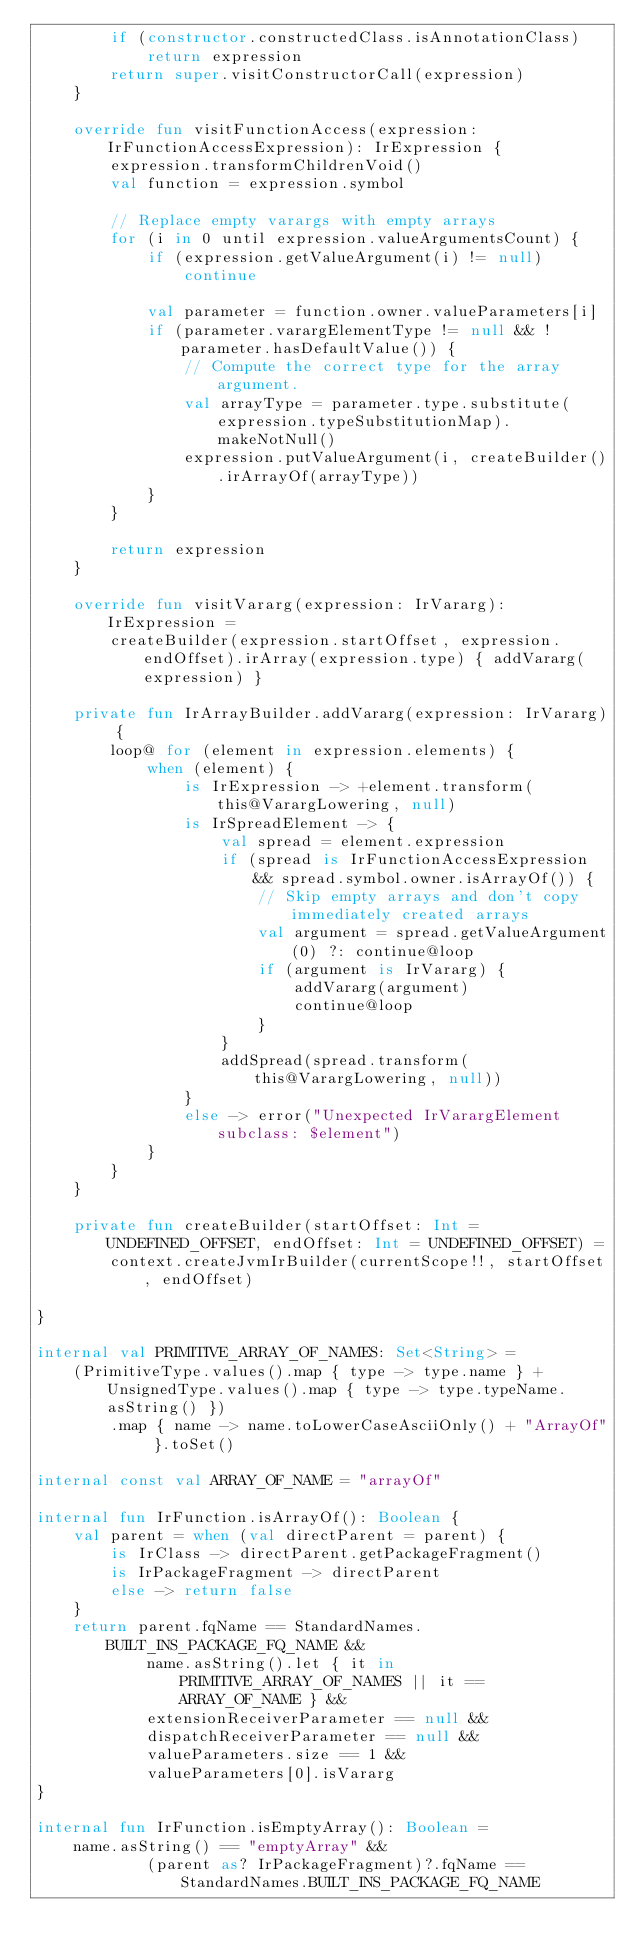Convert code to text. <code><loc_0><loc_0><loc_500><loc_500><_Kotlin_>        if (constructor.constructedClass.isAnnotationClass)
            return expression
        return super.visitConstructorCall(expression)
    }

    override fun visitFunctionAccess(expression: IrFunctionAccessExpression): IrExpression {
        expression.transformChildrenVoid()
        val function = expression.symbol

        // Replace empty varargs with empty arrays
        for (i in 0 until expression.valueArgumentsCount) {
            if (expression.getValueArgument(i) != null)
                continue

            val parameter = function.owner.valueParameters[i]
            if (parameter.varargElementType != null && !parameter.hasDefaultValue()) {
                // Compute the correct type for the array argument.
                val arrayType = parameter.type.substitute(expression.typeSubstitutionMap).makeNotNull()
                expression.putValueArgument(i, createBuilder().irArrayOf(arrayType))
            }
        }

        return expression
    }

    override fun visitVararg(expression: IrVararg): IrExpression =
        createBuilder(expression.startOffset, expression.endOffset).irArray(expression.type) { addVararg(expression) }

    private fun IrArrayBuilder.addVararg(expression: IrVararg) {
        loop@ for (element in expression.elements) {
            when (element) {
                is IrExpression -> +element.transform(this@VarargLowering, null)
                is IrSpreadElement -> {
                    val spread = element.expression
                    if (spread is IrFunctionAccessExpression && spread.symbol.owner.isArrayOf()) {
                        // Skip empty arrays and don't copy immediately created arrays
                        val argument = spread.getValueArgument(0) ?: continue@loop
                        if (argument is IrVararg) {
                            addVararg(argument)
                            continue@loop
                        }
                    }
                    addSpread(spread.transform(this@VarargLowering, null))
                }
                else -> error("Unexpected IrVarargElement subclass: $element")
            }
        }
    }

    private fun createBuilder(startOffset: Int = UNDEFINED_OFFSET, endOffset: Int = UNDEFINED_OFFSET) =
        context.createJvmIrBuilder(currentScope!!, startOffset, endOffset)

}

internal val PRIMITIVE_ARRAY_OF_NAMES: Set<String> =
    (PrimitiveType.values().map { type -> type.name } + UnsignedType.values().map { type -> type.typeName.asString() })
        .map { name -> name.toLowerCaseAsciiOnly() + "ArrayOf" }.toSet()

internal const val ARRAY_OF_NAME = "arrayOf"

internal fun IrFunction.isArrayOf(): Boolean {
    val parent = when (val directParent = parent) {
        is IrClass -> directParent.getPackageFragment()
        is IrPackageFragment -> directParent
        else -> return false
    }
    return parent.fqName == StandardNames.BUILT_INS_PACKAGE_FQ_NAME &&
            name.asString().let { it in PRIMITIVE_ARRAY_OF_NAMES || it == ARRAY_OF_NAME } &&
            extensionReceiverParameter == null &&
            dispatchReceiverParameter == null &&
            valueParameters.size == 1 &&
            valueParameters[0].isVararg
}

internal fun IrFunction.isEmptyArray(): Boolean =
    name.asString() == "emptyArray" &&
            (parent as? IrPackageFragment)?.fqName == StandardNames.BUILT_INS_PACKAGE_FQ_NAME</code> 